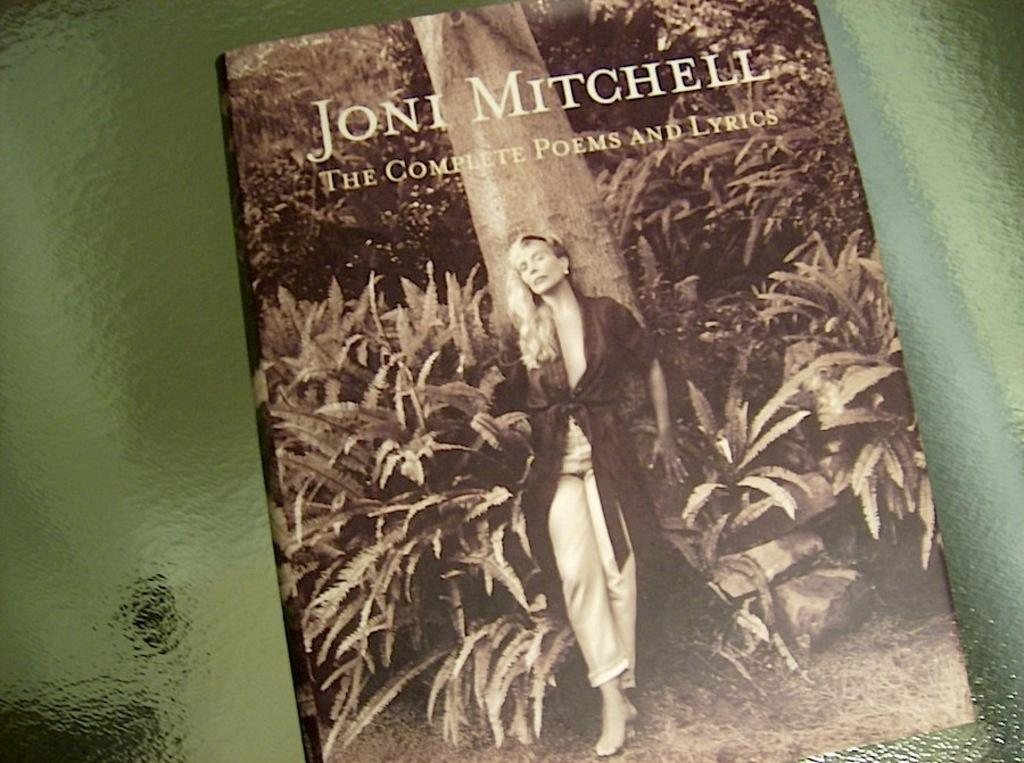What object is present in the image that is related to reading or learning? There is a book in the image. What is depicted on the cover of the book? The book has an image of a woman and plants. Where is the book located in the image? The book is placed on a table. Can you see any children playing on a playground in the image? There is no playground or children playing visible in the image; it only features a book with an image of a woman and plants. 